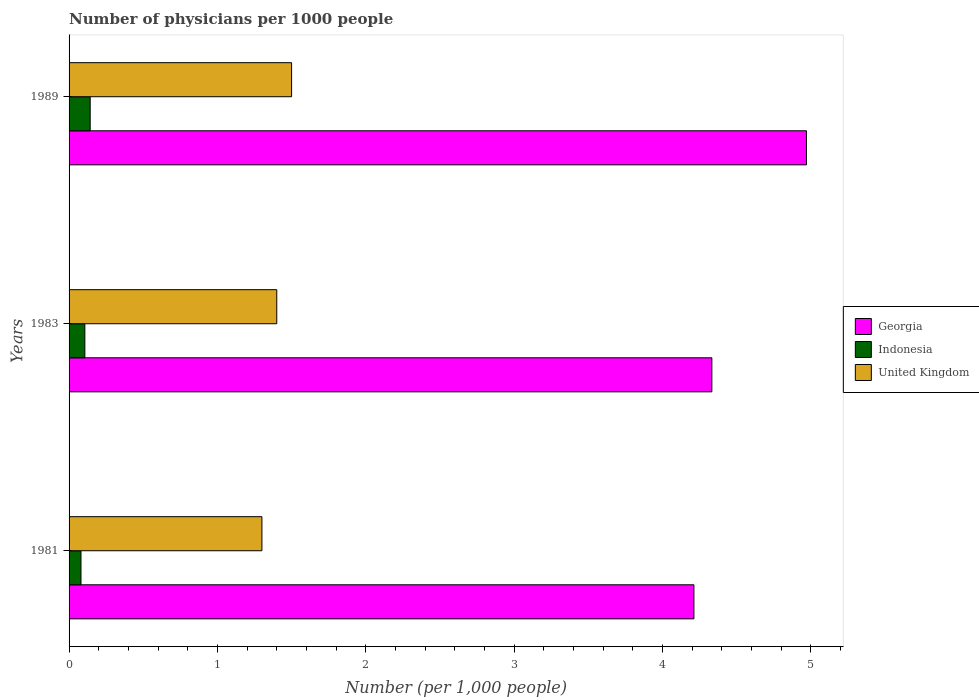How many different coloured bars are there?
Make the answer very short. 3. Are the number of bars on each tick of the Y-axis equal?
Your answer should be very brief. Yes. How many bars are there on the 3rd tick from the top?
Give a very brief answer. 3. What is the number of physicians in United Kingdom in 1989?
Your answer should be very brief. 1.5. Across all years, what is the maximum number of physicians in Indonesia?
Provide a short and direct response. 0.14. Across all years, what is the minimum number of physicians in Indonesia?
Your answer should be very brief. 0.08. What is the total number of physicians in Indonesia in the graph?
Your answer should be very brief. 0.33. What is the difference between the number of physicians in Indonesia in 1981 and that in 1989?
Provide a short and direct response. -0.06. What is the difference between the number of physicians in United Kingdom in 1981 and the number of physicians in Georgia in 1983?
Provide a short and direct response. -3.03. What is the average number of physicians in Georgia per year?
Provide a short and direct response. 4.51. In the year 1981, what is the difference between the number of physicians in Indonesia and number of physicians in Georgia?
Your answer should be compact. -4.13. What is the ratio of the number of physicians in Indonesia in 1981 to that in 1983?
Ensure brevity in your answer.  0.76. What is the difference between the highest and the second highest number of physicians in United Kingdom?
Give a very brief answer. 0.1. What is the difference between the highest and the lowest number of physicians in Georgia?
Make the answer very short. 0.76. In how many years, is the number of physicians in Indonesia greater than the average number of physicians in Indonesia taken over all years?
Offer a very short reply. 1. Is the sum of the number of physicians in Georgia in 1983 and 1989 greater than the maximum number of physicians in United Kingdom across all years?
Provide a succinct answer. Yes. What does the 2nd bar from the top in 1981 represents?
Your answer should be compact. Indonesia. What does the 3rd bar from the bottom in 1989 represents?
Offer a terse response. United Kingdom. Is it the case that in every year, the sum of the number of physicians in Indonesia and number of physicians in United Kingdom is greater than the number of physicians in Georgia?
Make the answer very short. No. How many years are there in the graph?
Make the answer very short. 3. What is the difference between two consecutive major ticks on the X-axis?
Your response must be concise. 1. Does the graph contain any zero values?
Provide a succinct answer. No. Does the graph contain grids?
Provide a short and direct response. No. Where does the legend appear in the graph?
Offer a very short reply. Center right. What is the title of the graph?
Give a very brief answer. Number of physicians per 1000 people. What is the label or title of the X-axis?
Your answer should be very brief. Number (per 1,0 people). What is the Number (per 1,000 people) in Georgia in 1981?
Offer a very short reply. 4.21. What is the Number (per 1,000 people) of Indonesia in 1981?
Make the answer very short. 0.08. What is the Number (per 1,000 people) in Georgia in 1983?
Ensure brevity in your answer.  4.33. What is the Number (per 1,000 people) in Indonesia in 1983?
Offer a very short reply. 0.11. What is the Number (per 1,000 people) in Georgia in 1989?
Provide a short and direct response. 4.97. What is the Number (per 1,000 people) in Indonesia in 1989?
Your answer should be very brief. 0.14. What is the Number (per 1,000 people) in United Kingdom in 1989?
Your response must be concise. 1.5. Across all years, what is the maximum Number (per 1,000 people) of Georgia?
Your answer should be compact. 4.97. Across all years, what is the maximum Number (per 1,000 people) of Indonesia?
Ensure brevity in your answer.  0.14. Across all years, what is the minimum Number (per 1,000 people) in Georgia?
Make the answer very short. 4.21. Across all years, what is the minimum Number (per 1,000 people) in Indonesia?
Give a very brief answer. 0.08. Across all years, what is the minimum Number (per 1,000 people) in United Kingdom?
Offer a terse response. 1.3. What is the total Number (per 1,000 people) in Georgia in the graph?
Your answer should be very brief. 13.52. What is the total Number (per 1,000 people) in Indonesia in the graph?
Your answer should be very brief. 0.33. What is the total Number (per 1,000 people) in United Kingdom in the graph?
Provide a succinct answer. 4.2. What is the difference between the Number (per 1,000 people) in Georgia in 1981 and that in 1983?
Your answer should be compact. -0.12. What is the difference between the Number (per 1,000 people) of Indonesia in 1981 and that in 1983?
Keep it short and to the point. -0.03. What is the difference between the Number (per 1,000 people) of United Kingdom in 1981 and that in 1983?
Offer a terse response. -0.1. What is the difference between the Number (per 1,000 people) of Georgia in 1981 and that in 1989?
Your answer should be very brief. -0.76. What is the difference between the Number (per 1,000 people) of Indonesia in 1981 and that in 1989?
Ensure brevity in your answer.  -0.06. What is the difference between the Number (per 1,000 people) in Georgia in 1983 and that in 1989?
Offer a terse response. -0.64. What is the difference between the Number (per 1,000 people) of Indonesia in 1983 and that in 1989?
Offer a very short reply. -0.04. What is the difference between the Number (per 1,000 people) in United Kingdom in 1983 and that in 1989?
Keep it short and to the point. -0.1. What is the difference between the Number (per 1,000 people) of Georgia in 1981 and the Number (per 1,000 people) of Indonesia in 1983?
Ensure brevity in your answer.  4.11. What is the difference between the Number (per 1,000 people) of Georgia in 1981 and the Number (per 1,000 people) of United Kingdom in 1983?
Your answer should be compact. 2.81. What is the difference between the Number (per 1,000 people) of Indonesia in 1981 and the Number (per 1,000 people) of United Kingdom in 1983?
Give a very brief answer. -1.32. What is the difference between the Number (per 1,000 people) in Georgia in 1981 and the Number (per 1,000 people) in Indonesia in 1989?
Make the answer very short. 4.07. What is the difference between the Number (per 1,000 people) in Georgia in 1981 and the Number (per 1,000 people) in United Kingdom in 1989?
Keep it short and to the point. 2.71. What is the difference between the Number (per 1,000 people) of Indonesia in 1981 and the Number (per 1,000 people) of United Kingdom in 1989?
Keep it short and to the point. -1.42. What is the difference between the Number (per 1,000 people) in Georgia in 1983 and the Number (per 1,000 people) in Indonesia in 1989?
Provide a short and direct response. 4.19. What is the difference between the Number (per 1,000 people) of Georgia in 1983 and the Number (per 1,000 people) of United Kingdom in 1989?
Your answer should be very brief. 2.83. What is the difference between the Number (per 1,000 people) of Indonesia in 1983 and the Number (per 1,000 people) of United Kingdom in 1989?
Ensure brevity in your answer.  -1.39. What is the average Number (per 1,000 people) in Georgia per year?
Ensure brevity in your answer.  4.51. What is the average Number (per 1,000 people) of Indonesia per year?
Provide a short and direct response. 0.11. What is the average Number (per 1,000 people) in United Kingdom per year?
Offer a very short reply. 1.4. In the year 1981, what is the difference between the Number (per 1,000 people) of Georgia and Number (per 1,000 people) of Indonesia?
Ensure brevity in your answer.  4.13. In the year 1981, what is the difference between the Number (per 1,000 people) in Georgia and Number (per 1,000 people) in United Kingdom?
Make the answer very short. 2.91. In the year 1981, what is the difference between the Number (per 1,000 people) of Indonesia and Number (per 1,000 people) of United Kingdom?
Give a very brief answer. -1.22. In the year 1983, what is the difference between the Number (per 1,000 people) of Georgia and Number (per 1,000 people) of Indonesia?
Your response must be concise. 4.23. In the year 1983, what is the difference between the Number (per 1,000 people) of Georgia and Number (per 1,000 people) of United Kingdom?
Ensure brevity in your answer.  2.93. In the year 1983, what is the difference between the Number (per 1,000 people) of Indonesia and Number (per 1,000 people) of United Kingdom?
Make the answer very short. -1.29. In the year 1989, what is the difference between the Number (per 1,000 people) in Georgia and Number (per 1,000 people) in Indonesia?
Give a very brief answer. 4.83. In the year 1989, what is the difference between the Number (per 1,000 people) of Georgia and Number (per 1,000 people) of United Kingdom?
Keep it short and to the point. 3.47. In the year 1989, what is the difference between the Number (per 1,000 people) of Indonesia and Number (per 1,000 people) of United Kingdom?
Ensure brevity in your answer.  -1.36. What is the ratio of the Number (per 1,000 people) of Georgia in 1981 to that in 1983?
Your answer should be compact. 0.97. What is the ratio of the Number (per 1,000 people) of Indonesia in 1981 to that in 1983?
Provide a short and direct response. 0.76. What is the ratio of the Number (per 1,000 people) of United Kingdom in 1981 to that in 1983?
Provide a succinct answer. 0.93. What is the ratio of the Number (per 1,000 people) in Georgia in 1981 to that in 1989?
Provide a short and direct response. 0.85. What is the ratio of the Number (per 1,000 people) of Indonesia in 1981 to that in 1989?
Keep it short and to the point. 0.56. What is the ratio of the Number (per 1,000 people) of United Kingdom in 1981 to that in 1989?
Give a very brief answer. 0.87. What is the ratio of the Number (per 1,000 people) in Georgia in 1983 to that in 1989?
Provide a short and direct response. 0.87. What is the ratio of the Number (per 1,000 people) in Indonesia in 1983 to that in 1989?
Provide a succinct answer. 0.75. What is the difference between the highest and the second highest Number (per 1,000 people) in Georgia?
Provide a short and direct response. 0.64. What is the difference between the highest and the second highest Number (per 1,000 people) of Indonesia?
Give a very brief answer. 0.04. What is the difference between the highest and the second highest Number (per 1,000 people) of United Kingdom?
Your response must be concise. 0.1. What is the difference between the highest and the lowest Number (per 1,000 people) of Georgia?
Provide a succinct answer. 0.76. What is the difference between the highest and the lowest Number (per 1,000 people) in Indonesia?
Give a very brief answer. 0.06. What is the difference between the highest and the lowest Number (per 1,000 people) of United Kingdom?
Provide a succinct answer. 0.2. 